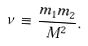<formula> <loc_0><loc_0><loc_500><loc_500>\nu \equiv \frac { m _ { 1 } m _ { 2 } } { M ^ { 2 } } .</formula> 